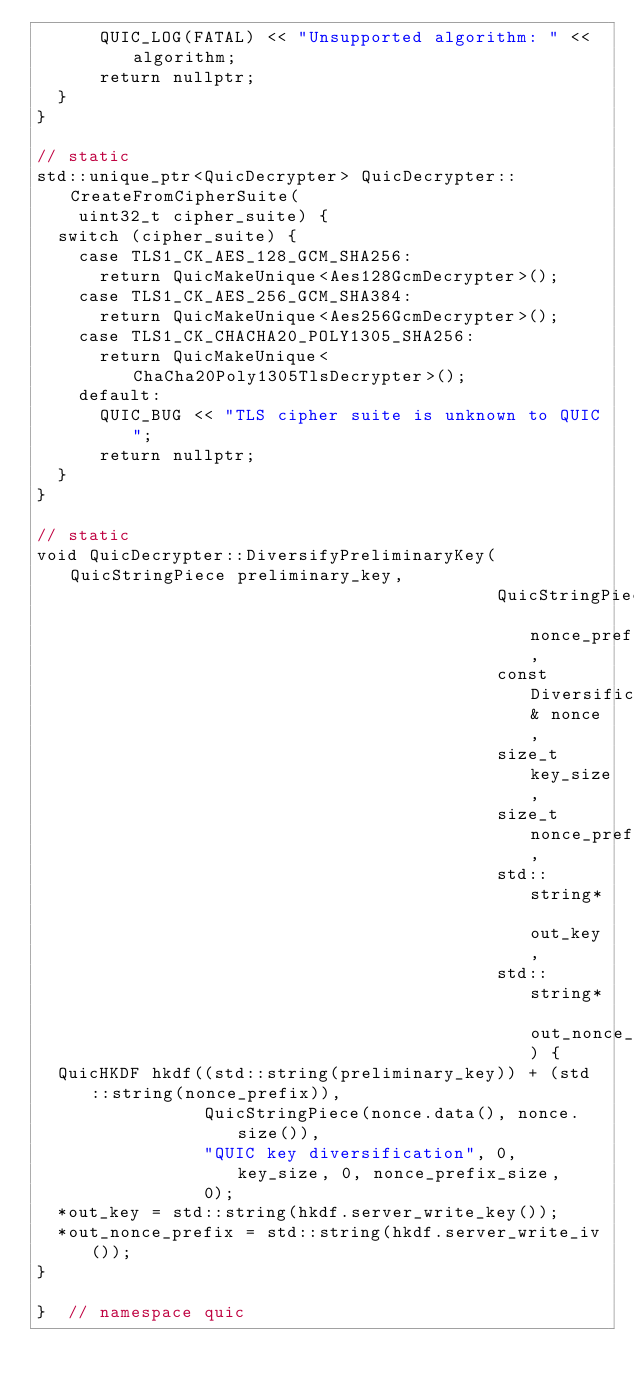<code> <loc_0><loc_0><loc_500><loc_500><_C++_>      QUIC_LOG(FATAL) << "Unsupported algorithm: " << algorithm;
      return nullptr;
  }
}

// static
std::unique_ptr<QuicDecrypter> QuicDecrypter::CreateFromCipherSuite(
    uint32_t cipher_suite) {
  switch (cipher_suite) {
    case TLS1_CK_AES_128_GCM_SHA256:
      return QuicMakeUnique<Aes128GcmDecrypter>();
    case TLS1_CK_AES_256_GCM_SHA384:
      return QuicMakeUnique<Aes256GcmDecrypter>();
    case TLS1_CK_CHACHA20_POLY1305_SHA256:
      return QuicMakeUnique<ChaCha20Poly1305TlsDecrypter>();
    default:
      QUIC_BUG << "TLS cipher suite is unknown to QUIC";
      return nullptr;
  }
}

// static
void QuicDecrypter::DiversifyPreliminaryKey(QuicStringPiece preliminary_key,
                                            QuicStringPiece nonce_prefix,
                                            const DiversificationNonce& nonce,
                                            size_t key_size,
                                            size_t nonce_prefix_size,
                                            std::string* out_key,
                                            std::string* out_nonce_prefix) {
  QuicHKDF hkdf((std::string(preliminary_key)) + (std::string(nonce_prefix)),
                QuicStringPiece(nonce.data(), nonce.size()),
                "QUIC key diversification", 0, key_size, 0, nonce_prefix_size,
                0);
  *out_key = std::string(hkdf.server_write_key());
  *out_nonce_prefix = std::string(hkdf.server_write_iv());
}

}  // namespace quic
</code> 